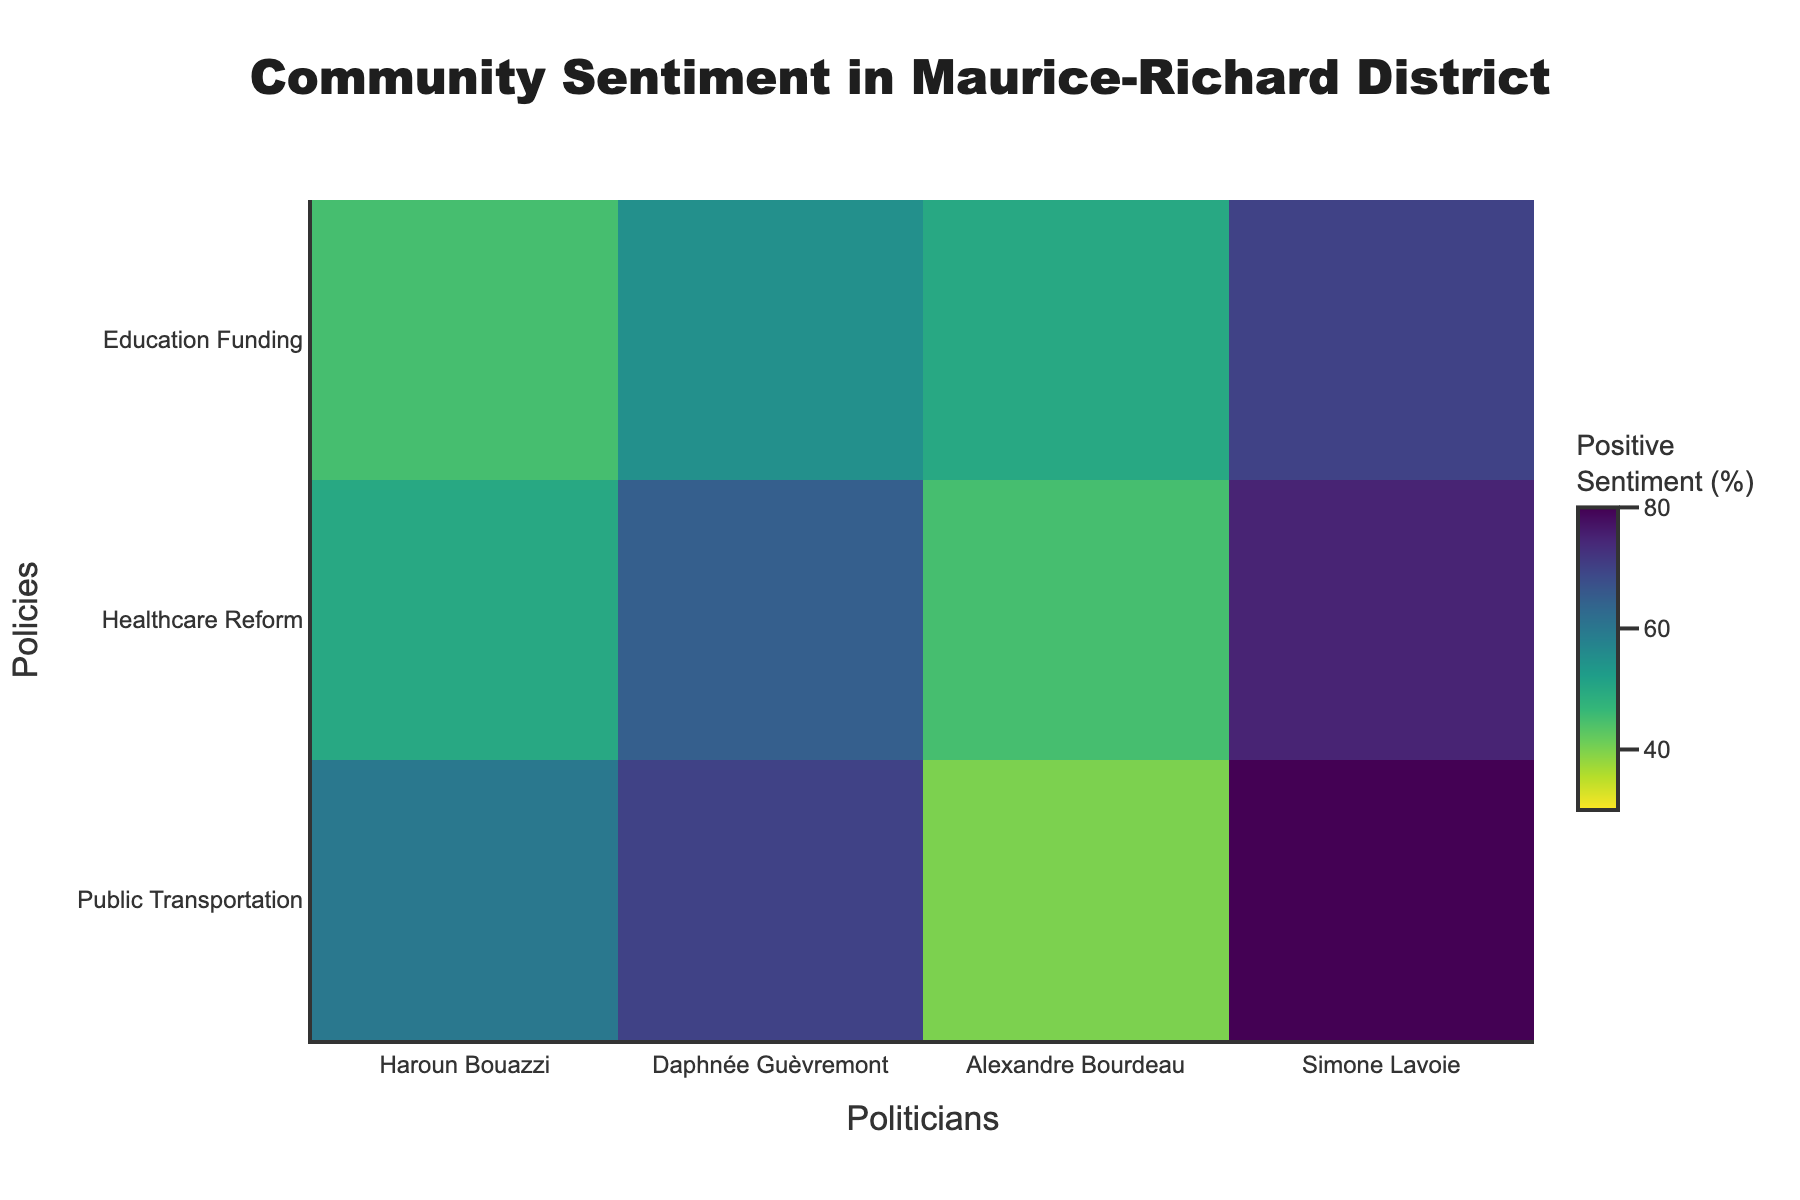How many politicians are shown in the figure? Count the unique names along the x-axis.
Answer: 4 What is the positive sentiment percentage for Haroun Bouazzi regarding Public Transportation? Look at the heatmap intersection for Haroun Bouazzi and Public Transportation and check the corresponding percentage.
Answer: 60% Which policy has the highest positive sentiment for Simone Lavoie? Compare the positive sentiment percentages for all policies listed under Simone Lavoie and find the highest value.
Answer: Public Transportation Who has the lowest positive sentiment for Healthcare Reform? Locate the Healthcare Reform row and identify the smallest percentage among the politicians for this policy.
Answer: Alexandre Bourdeau Compare the positive sentiment for Education Funding between Daphnée Guèvremont and Haroun Bouazzi. Which one is higher? Check the positive sentiment percentages for Education Funding for both politicians and compare them.
Answer: Daphnée Guèvremont What is the average positive sentiment for Public Transportation across all politicians? Sum the positive sentiment percentages for Public Transportation from all politicians and divide by the number of politicians. The values are 60, 70, 40, 80; thus, the sum is 250 and the average is 250/4 = 62.5
Answer: 62.5 Is there any policy for which Alexandre Bourdeau receives a higher positive sentiment than Haroun Bouazzi? Compare the positive sentiment values for each policy between Alexandre Bourdeau and Haroun Bouazzi.
Answer: No What is the range of positive sentiment percentages for Daphnée Guèvremont across all policies? Identify the highest and lowest sentiment percentages for Daphnée Guèvremont, then calculate the difference. The highest is 70 and the lowest is 55; thus, the range is 70 - 55 = 15
Answer: 15 Which politician shows the most consistent positive sentiment across all policies? Compare the variance of positive sentiment percentages for each politician. The one with the smallest variance is the most consistent.
Answer: Simone Lavoie 